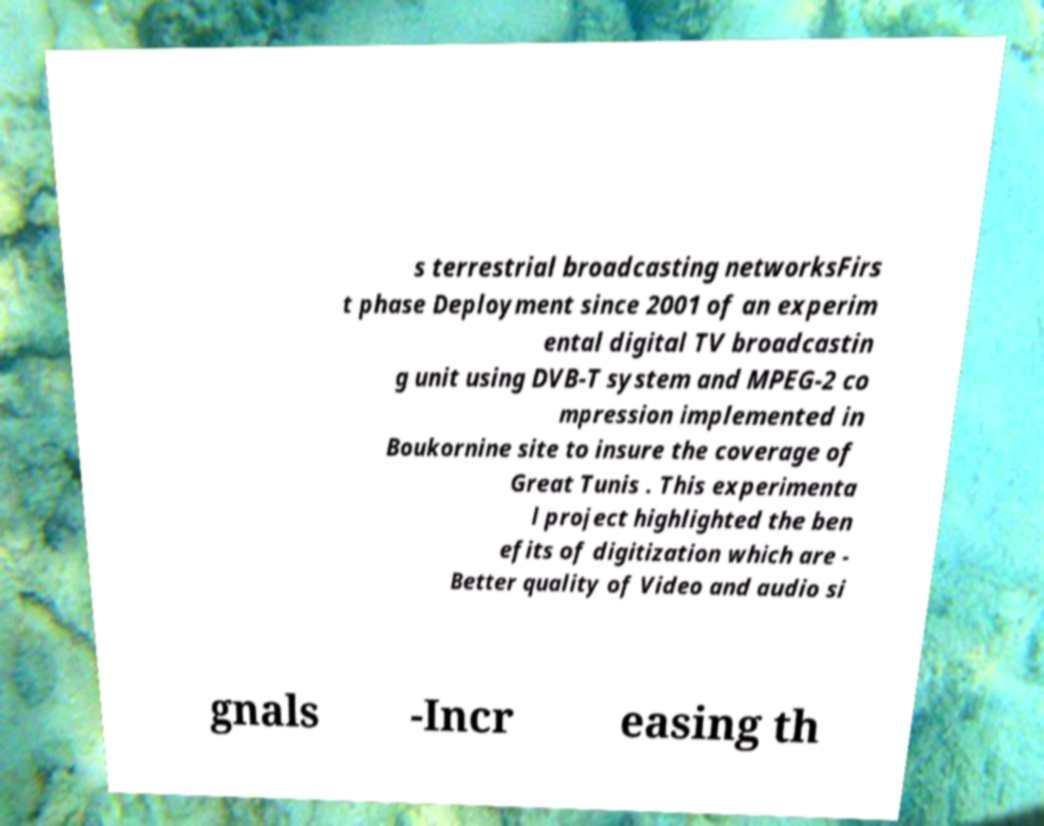Could you assist in decoding the text presented in this image and type it out clearly? s terrestrial broadcasting networksFirs t phase Deployment since 2001 of an experim ental digital TV broadcastin g unit using DVB-T system and MPEG-2 co mpression implemented in Boukornine site to insure the coverage of Great Tunis . This experimenta l project highlighted the ben efits of digitization which are - Better quality of Video and audio si gnals -Incr easing th 